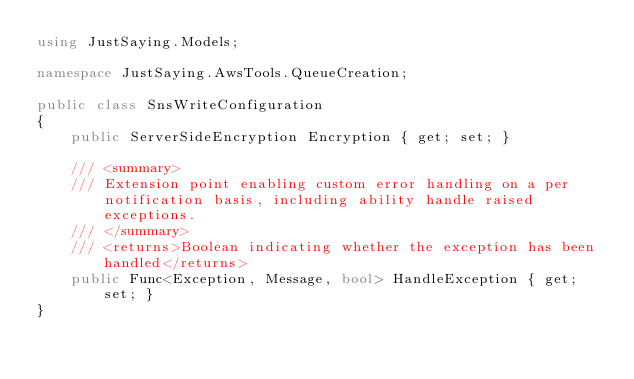<code> <loc_0><loc_0><loc_500><loc_500><_C#_>using JustSaying.Models;

namespace JustSaying.AwsTools.QueueCreation;

public class SnsWriteConfiguration
{
    public ServerSideEncryption Encryption { get; set; }

    /// <summary>
    /// Extension point enabling custom error handling on a per notification basis, including ability handle raised exceptions.
    /// </summary>
    /// <returns>Boolean indicating whether the exception has been handled</returns>
    public Func<Exception, Message, bool> HandleException { get; set; }
}</code> 